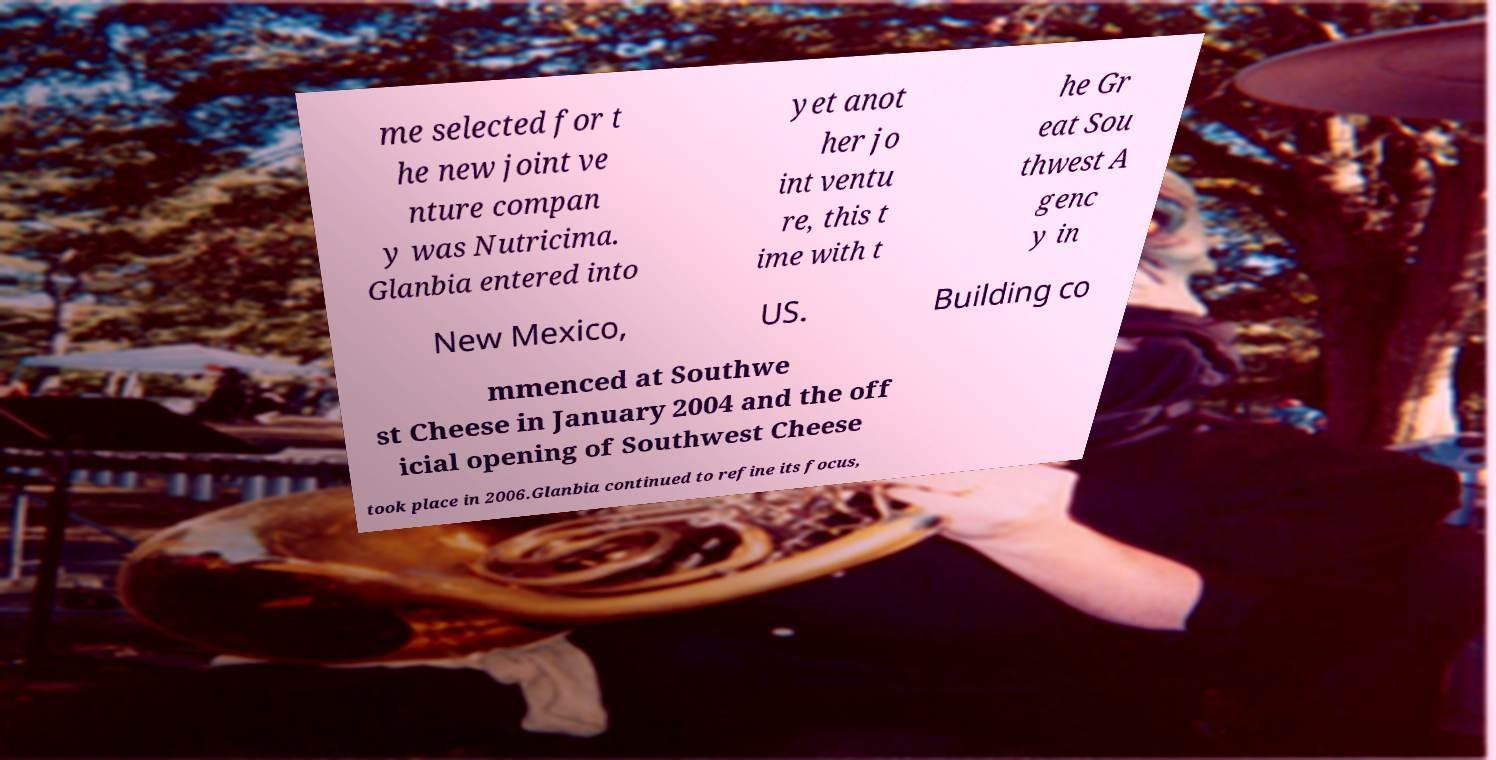Please identify and transcribe the text found in this image. me selected for t he new joint ve nture compan y was Nutricima. Glanbia entered into yet anot her jo int ventu re, this t ime with t he Gr eat Sou thwest A genc y in New Mexico, US. Building co mmenced at Southwe st Cheese in January 2004 and the off icial opening of Southwest Cheese took place in 2006.Glanbia continued to refine its focus, 